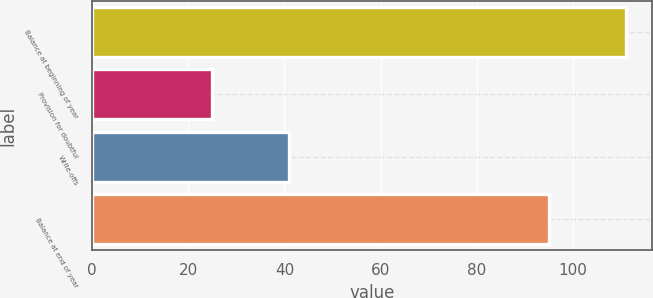Convert chart to OTSL. <chart><loc_0><loc_0><loc_500><loc_500><bar_chart><fcel>Balance at beginning of year<fcel>Provision for doubtful<fcel>Write-offs<fcel>Balance at end of year<nl><fcel>111<fcel>25<fcel>41<fcel>95<nl></chart> 